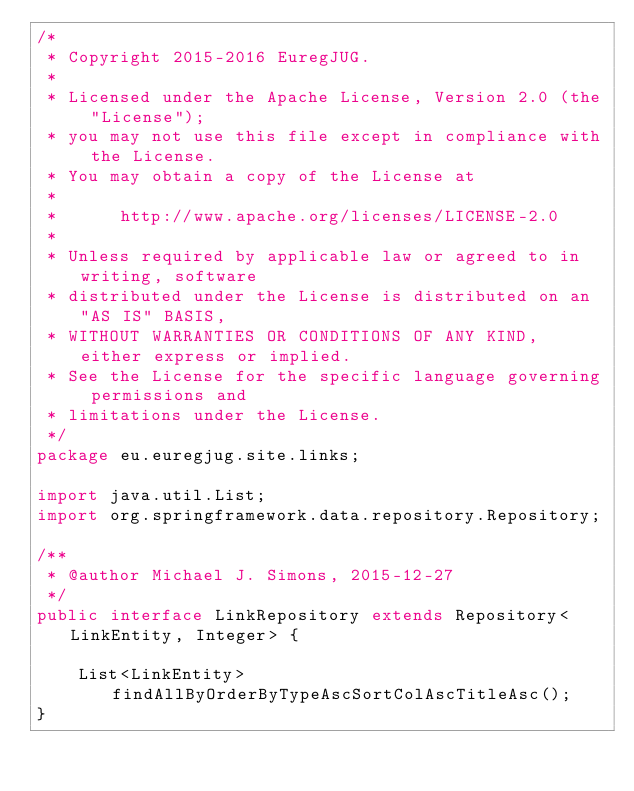<code> <loc_0><loc_0><loc_500><loc_500><_Java_>/*
 * Copyright 2015-2016 EuregJUG.
 *
 * Licensed under the Apache License, Version 2.0 (the "License");
 * you may not use this file except in compliance with the License.
 * You may obtain a copy of the License at
 *
 *      http://www.apache.org/licenses/LICENSE-2.0
 *
 * Unless required by applicable law or agreed to in writing, software
 * distributed under the License is distributed on an "AS IS" BASIS,
 * WITHOUT WARRANTIES OR CONDITIONS OF ANY KIND, either express or implied.
 * See the License for the specific language governing permissions and
 * limitations under the License.
 */
package eu.euregjug.site.links;

import java.util.List;
import org.springframework.data.repository.Repository;

/**
 * @author Michael J. Simons, 2015-12-27
 */
public interface LinkRepository extends Repository<LinkEntity, Integer> {

    List<LinkEntity> findAllByOrderByTypeAscSortColAscTitleAsc();
}
</code> 